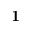Convert formula to latex. <formula><loc_0><loc_0><loc_500><loc_500>1</formula> 